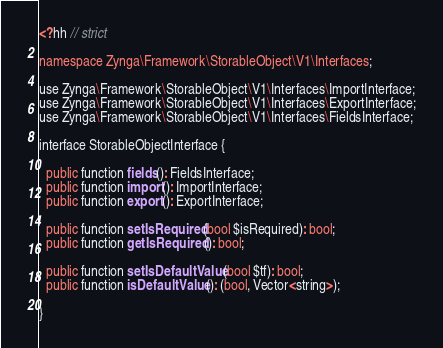<code> <loc_0><loc_0><loc_500><loc_500><_C++_><?hh // strict

namespace Zynga\Framework\StorableObject\V1\Interfaces;

use Zynga\Framework\StorableObject\V1\Interfaces\ImportInterface;
use Zynga\Framework\StorableObject\V1\Interfaces\ExportInterface;
use Zynga\Framework\StorableObject\V1\Interfaces\FieldsInterface;

interface StorableObjectInterface {

  public function fields(): FieldsInterface;
  public function import(): ImportInterface;
  public function export(): ExportInterface;

  public function setIsRequired(bool $isRequired): bool;
  public function getIsRequired(): bool;

  public function setIsDefaultValue(bool $tf): bool;
  public function isDefaultValue(): (bool, Vector<string>);

}
</code> 